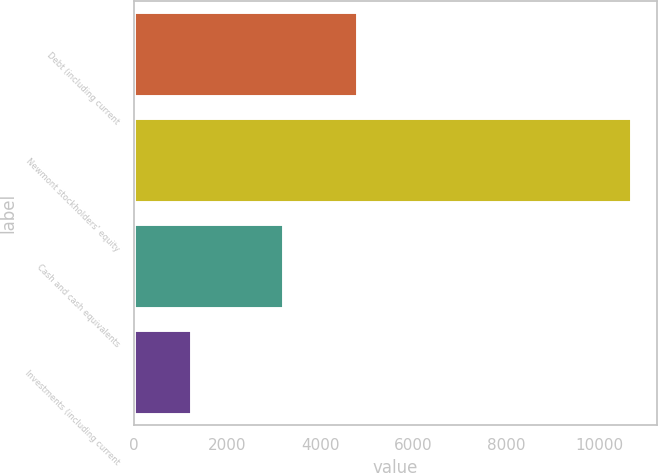Convert chart to OTSL. <chart><loc_0><loc_0><loc_500><loc_500><bar_chart><fcel>Debt (including current<fcel>Newmont stockholders' equity<fcel>Cash and cash equivalents<fcel>Investments (including current<nl><fcel>4809<fcel>10703<fcel>3215<fcel>1242<nl></chart> 